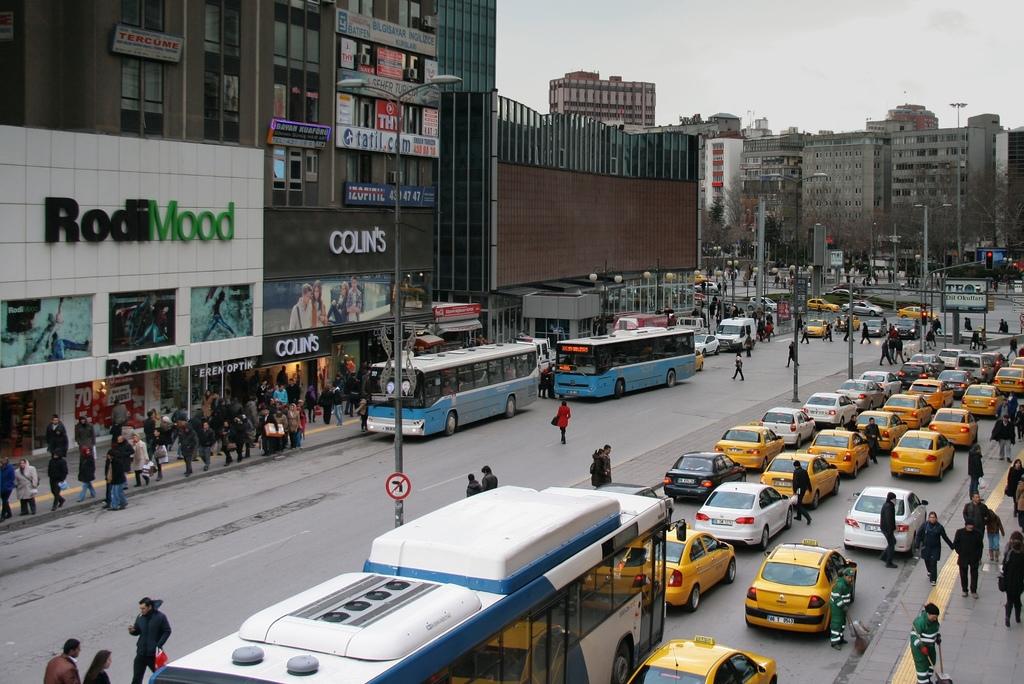Whats the name of the store next to rodimood?
Your answer should be very brief. Colin's. 